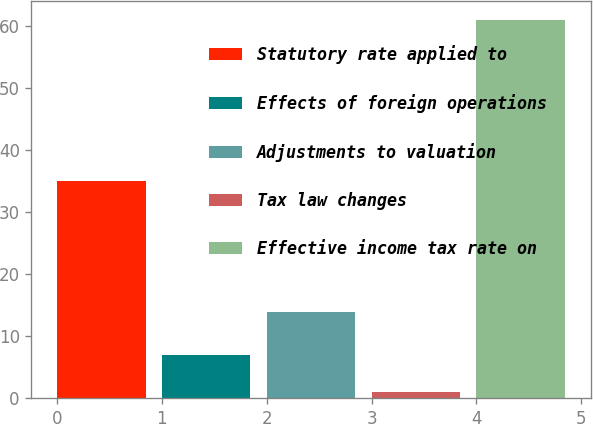Convert chart. <chart><loc_0><loc_0><loc_500><loc_500><bar_chart><fcel>Statutory rate applied to<fcel>Effects of foreign operations<fcel>Adjustments to valuation<fcel>Tax law changes<fcel>Effective income tax rate on<nl><fcel>35<fcel>7<fcel>14<fcel>1<fcel>61<nl></chart> 